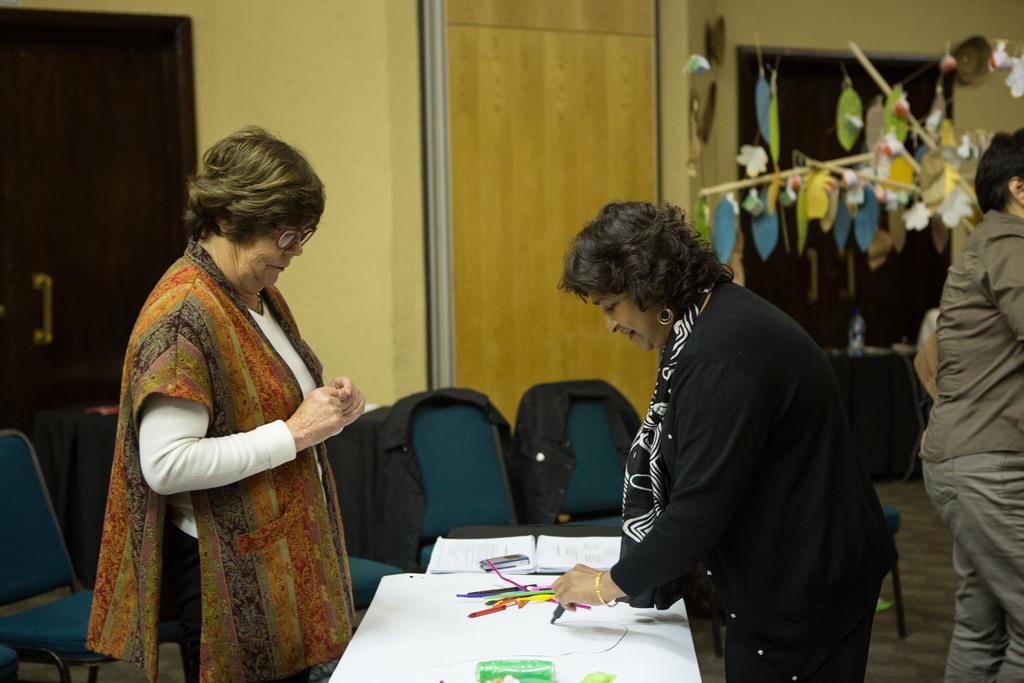Can you describe this image briefly? This picture might be taken inside the room. In this image, on the right side, we can see a woman wearing a black color dress and holding a pen in her hand, she is also standing in front of the table. On the right side, we can also see a man standing on the floor. On the left side, we can also see a woman wearing a white color shirt is standing. On that table, we can see some pens, papers, books. In the background, we can see some chairs, door which is closed. 